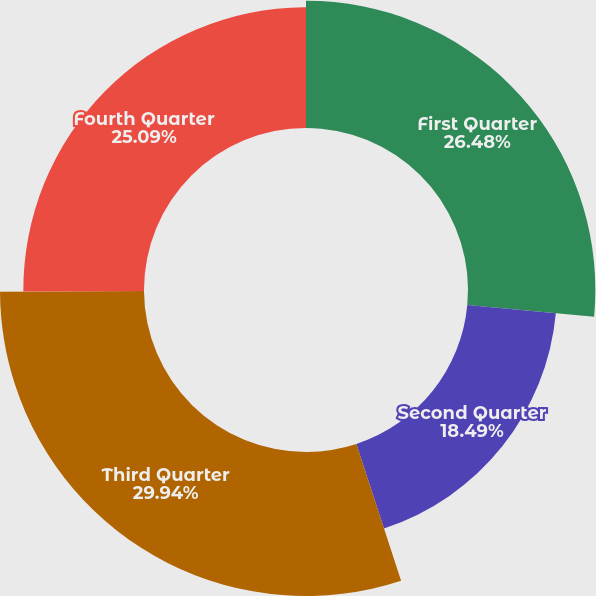<chart> <loc_0><loc_0><loc_500><loc_500><pie_chart><fcel>First Quarter<fcel>Second Quarter<fcel>Third Quarter<fcel>Fourth Quarter<nl><fcel>26.48%<fcel>18.49%<fcel>29.94%<fcel>25.09%<nl></chart> 